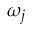<formula> <loc_0><loc_0><loc_500><loc_500>\omega _ { j }</formula> 